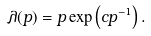Convert formula to latex. <formula><loc_0><loc_0><loc_500><loc_500>\lambda ( p ) = p \exp \left ( c p ^ { - 1 } \right ) .</formula> 